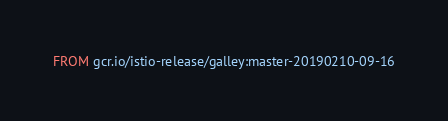Convert code to text. <code><loc_0><loc_0><loc_500><loc_500><_Dockerfile_>FROM gcr.io/istio-release/galley:master-20190210-09-16
</code> 